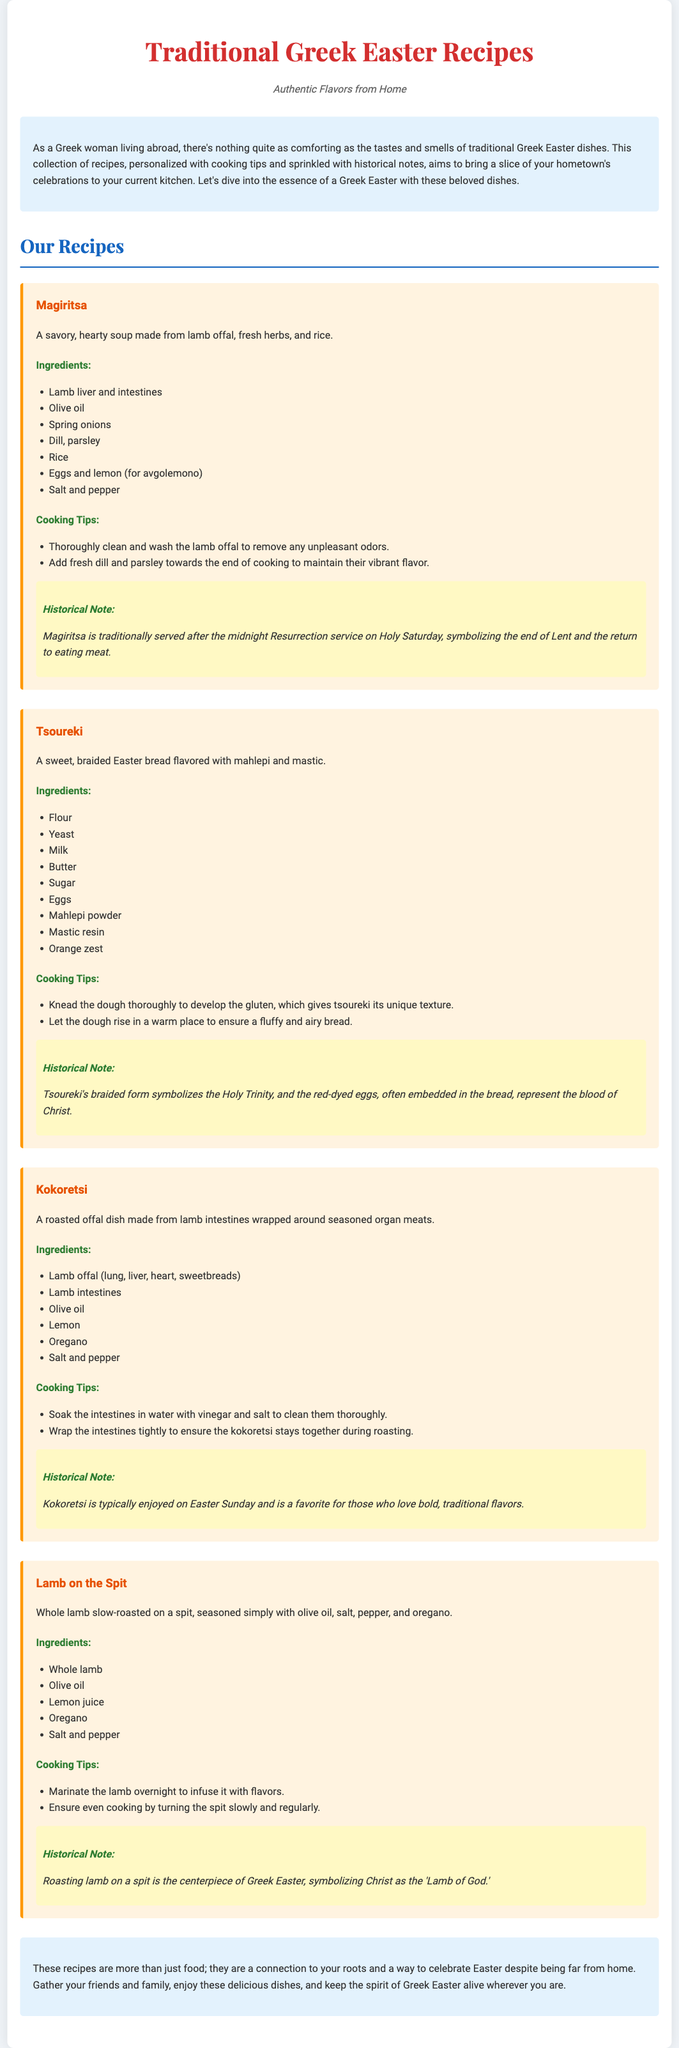what is the title of the document? The title is declared in the head section of the document, which is "Traditional Greek Easter Recipes."
Answer: Traditional Greek Easter Recipes how many recipes are included in the collection? The document lists four recipes in the collection.
Answer: Four what is the main ingredient in Magiritsa? The main ingredient for Magiritsa is lamb offal.
Answer: Lamb offal what does Tsoureki symbolize? The braided form of Tsoureki symbolizes the Holy Trinity.
Answer: Holy Trinity which dish is traditionally served after the midnight Resurrection service? The dish served after the midnight Resurrection service is Magiritsa.
Answer: Magiritsa what is included in the cooking tips for Kokoretsi? The cooking tips for Kokoretsi include soaking the intestines in water with vinegar and salt.
Answer: Soak intestines in water with vinegar and salt what historical note is provided for Lamb on the Spit? The historical note explains that roasting lamb on a spit symbolizes Christ as the 'Lamb of God.'
Answer: Christ as the 'Lamb of God' what type of document is this collection? The document is a recipe collection that includes recipes and cooking tips.
Answer: Recipe collection 